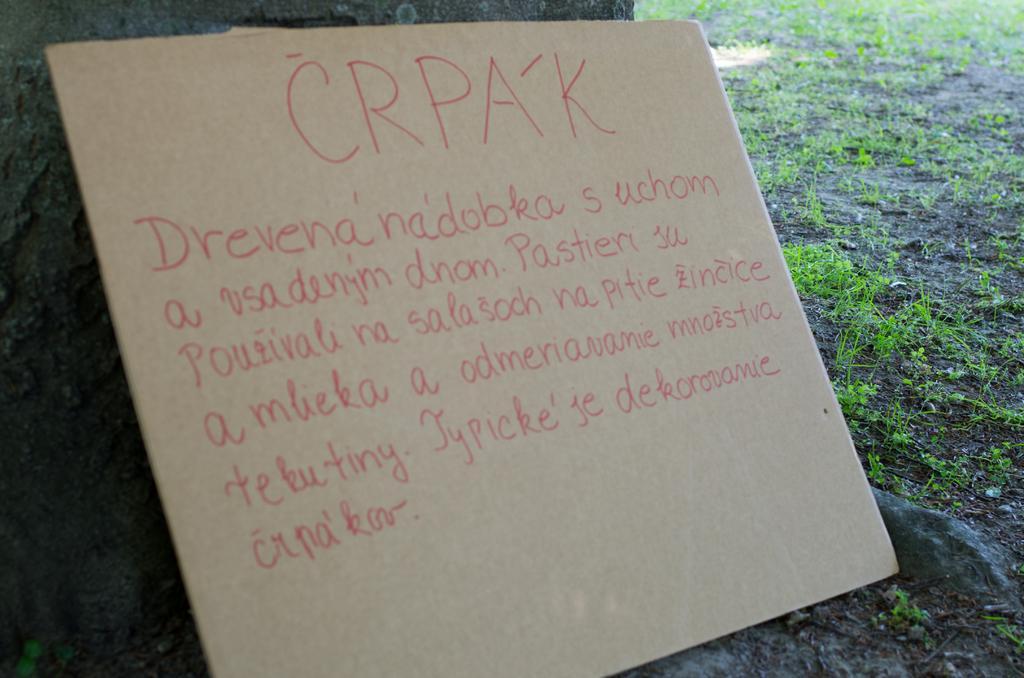In one or two sentences, can you explain what this image depicts? In this image in the front there is a board with some text written on it and in the background there is grass on the ground. 